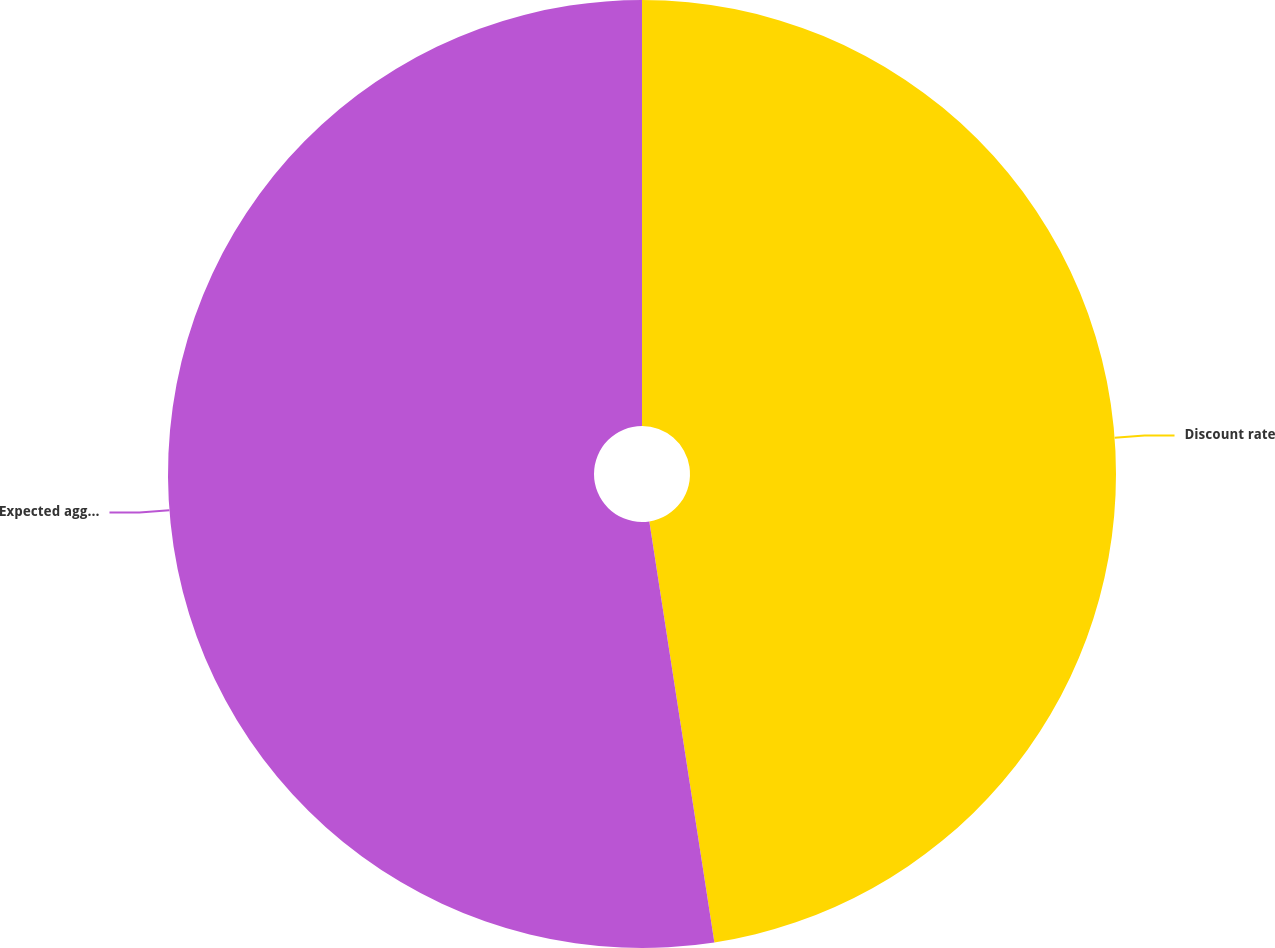<chart> <loc_0><loc_0><loc_500><loc_500><pie_chart><fcel>Discount rate<fcel>Expected aggregate average<nl><fcel>47.56%<fcel>52.44%<nl></chart> 